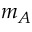<formula> <loc_0><loc_0><loc_500><loc_500>m _ { A }</formula> 